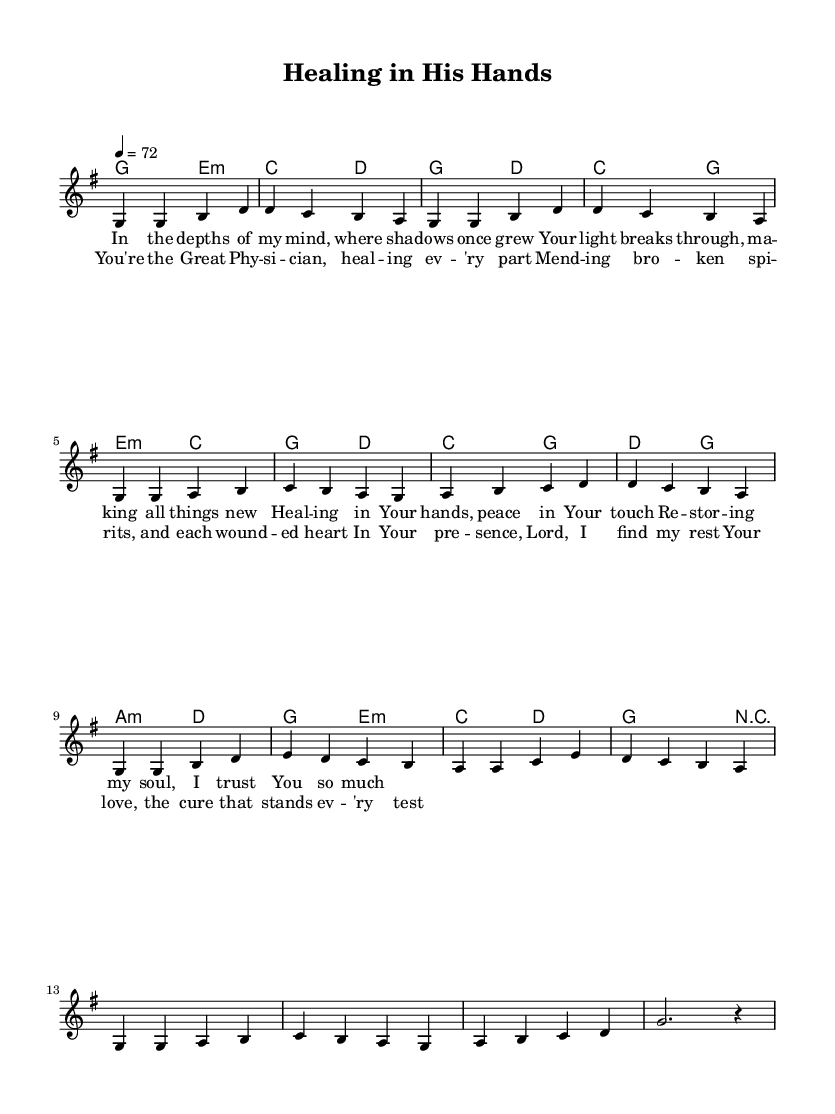What is the key signature of this music? The key signature indicated in the score is G major, which has one sharp (F#). This can be identified at the beginning of the staff, where the sharp is placed on the F line.
Answer: G major What is the time signature of the piece? The time signature shown at the beginning of the score is 4/4, which means there are four beats in each measure and the quarter note receives one beat. This is easily identifiable as it is notated at the start of the music.
Answer: 4/4 What is the tempo marking of the piece? The tempo marking is indicated as 4 = 72, meaning that there are 72 beats per minute, with each quarter note representing one beat. This notation appears at the beginning of the score, under the time signature.
Answer: 72 How many measures are in the chorus? By counting the measures in the chorus section, we find there are four measures. Each measure typically corresponds to the musical phrases that align with the lyrics, which can be verified visually by grouping the music into the corresponding lyrics.
Answer: Four Which chords are used in the harmony section? The chords used in the harmony section include G, E minor, C, D, and A minor. These chords are labeled above the staff and represent the chordal accompaniment for the melody.
Answer: G, E minor, C, D, A minor What is the theme expressed in the lyrics of the verse? The theme of the verse revolves around mental health and healing, mentioning phrases like "light breaks through" and "restoring my soul". This relates to the spiritual aspect of finding support and solace in faith, which is a common theme in contemporary Christian music.
Answer: Healing and restoration How many lines are in the entire song? The song consists of a total of 8 lines, with 4 lines in the verse and 4 lines in the chorus. This can be counted by observing the structure of the lyrics beneath the melody, where each line of lyrics corresponds to a musical phrase.
Answer: Eight 